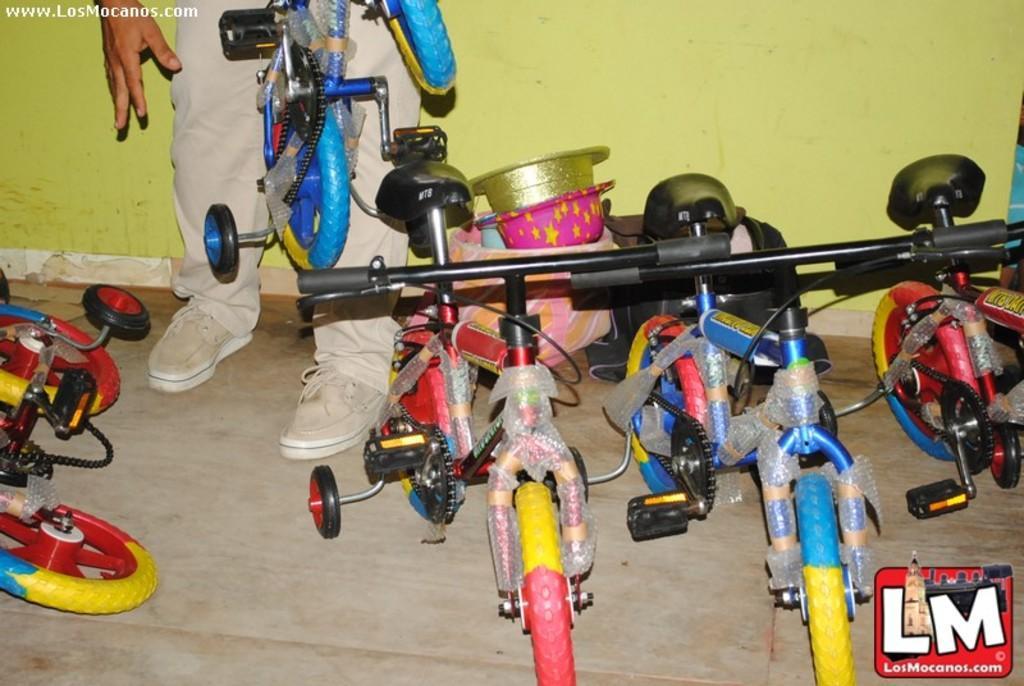Please provide a concise description of this image. In this image we can see some bicycles, hats, also we can see a person, and also we can see the wall. 